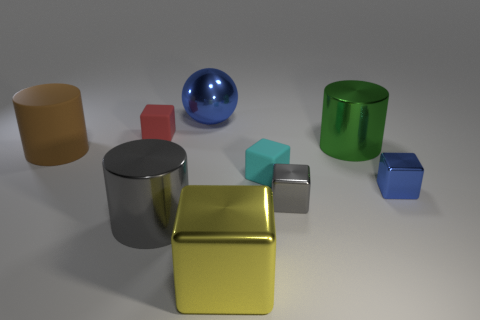Subtract all metal blocks. How many blocks are left? 2 Subtract all blue cubes. How many cubes are left? 4 Subtract all spheres. How many objects are left? 8 Subtract 0 purple cubes. How many objects are left? 9 Subtract 4 blocks. How many blocks are left? 1 Subtract all red balls. Subtract all purple cubes. How many balls are left? 1 Subtract all brown cylinders. How many red cubes are left? 1 Subtract all tiny shiny spheres. Subtract all gray metal cylinders. How many objects are left? 8 Add 1 cyan cubes. How many cyan cubes are left? 2 Add 3 large gray shiny things. How many large gray shiny things exist? 4 